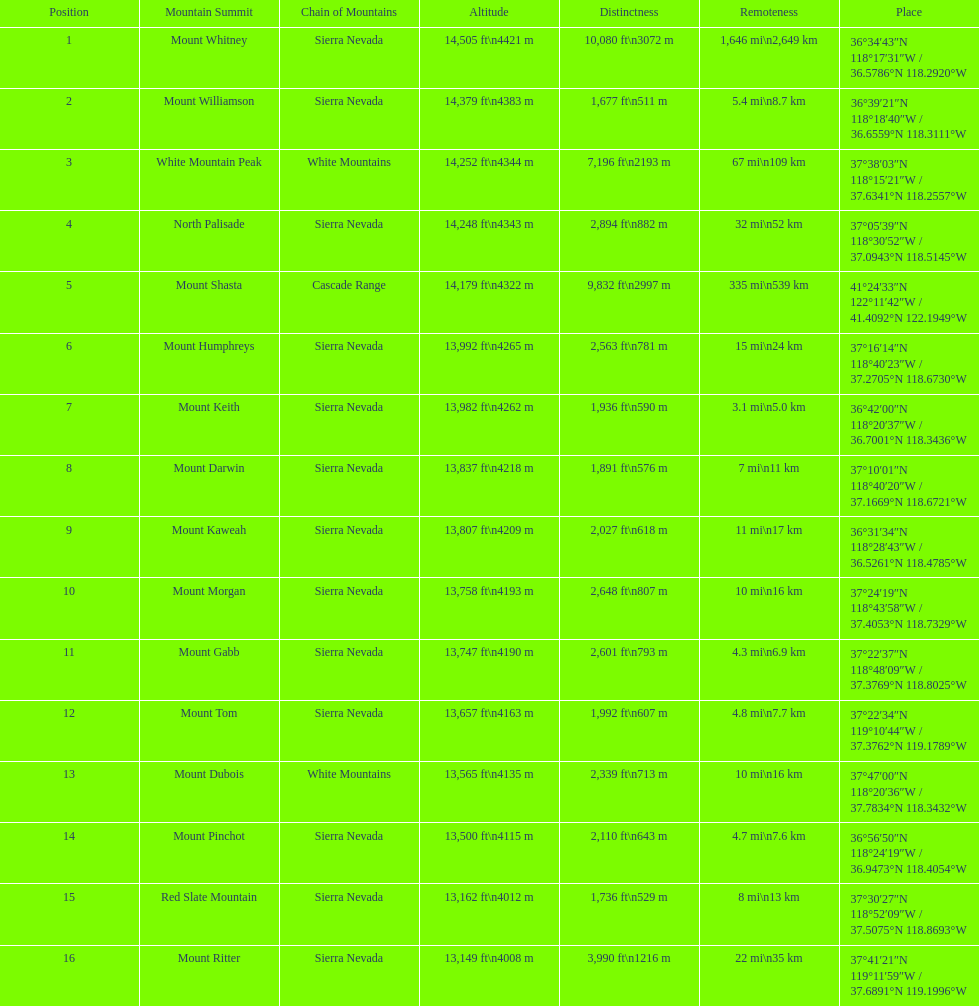Which mountain peak is the only mountain peak in the cascade range? Mount Shasta. 